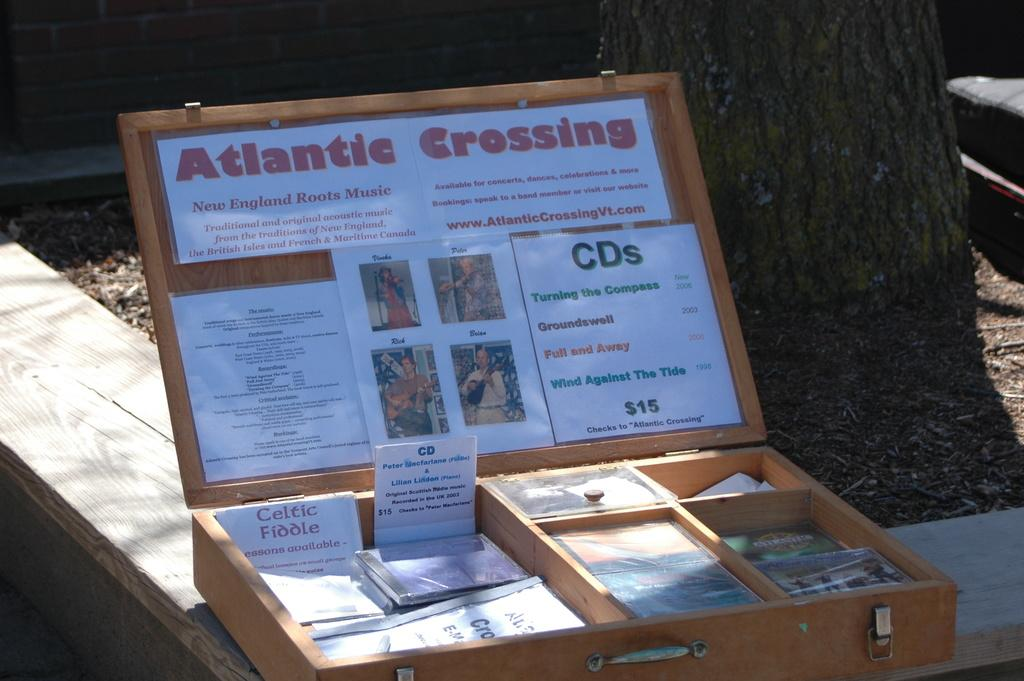Provide a one-sentence caption for the provided image. An open wooden box with the words Atlantic Crossing on the top. 